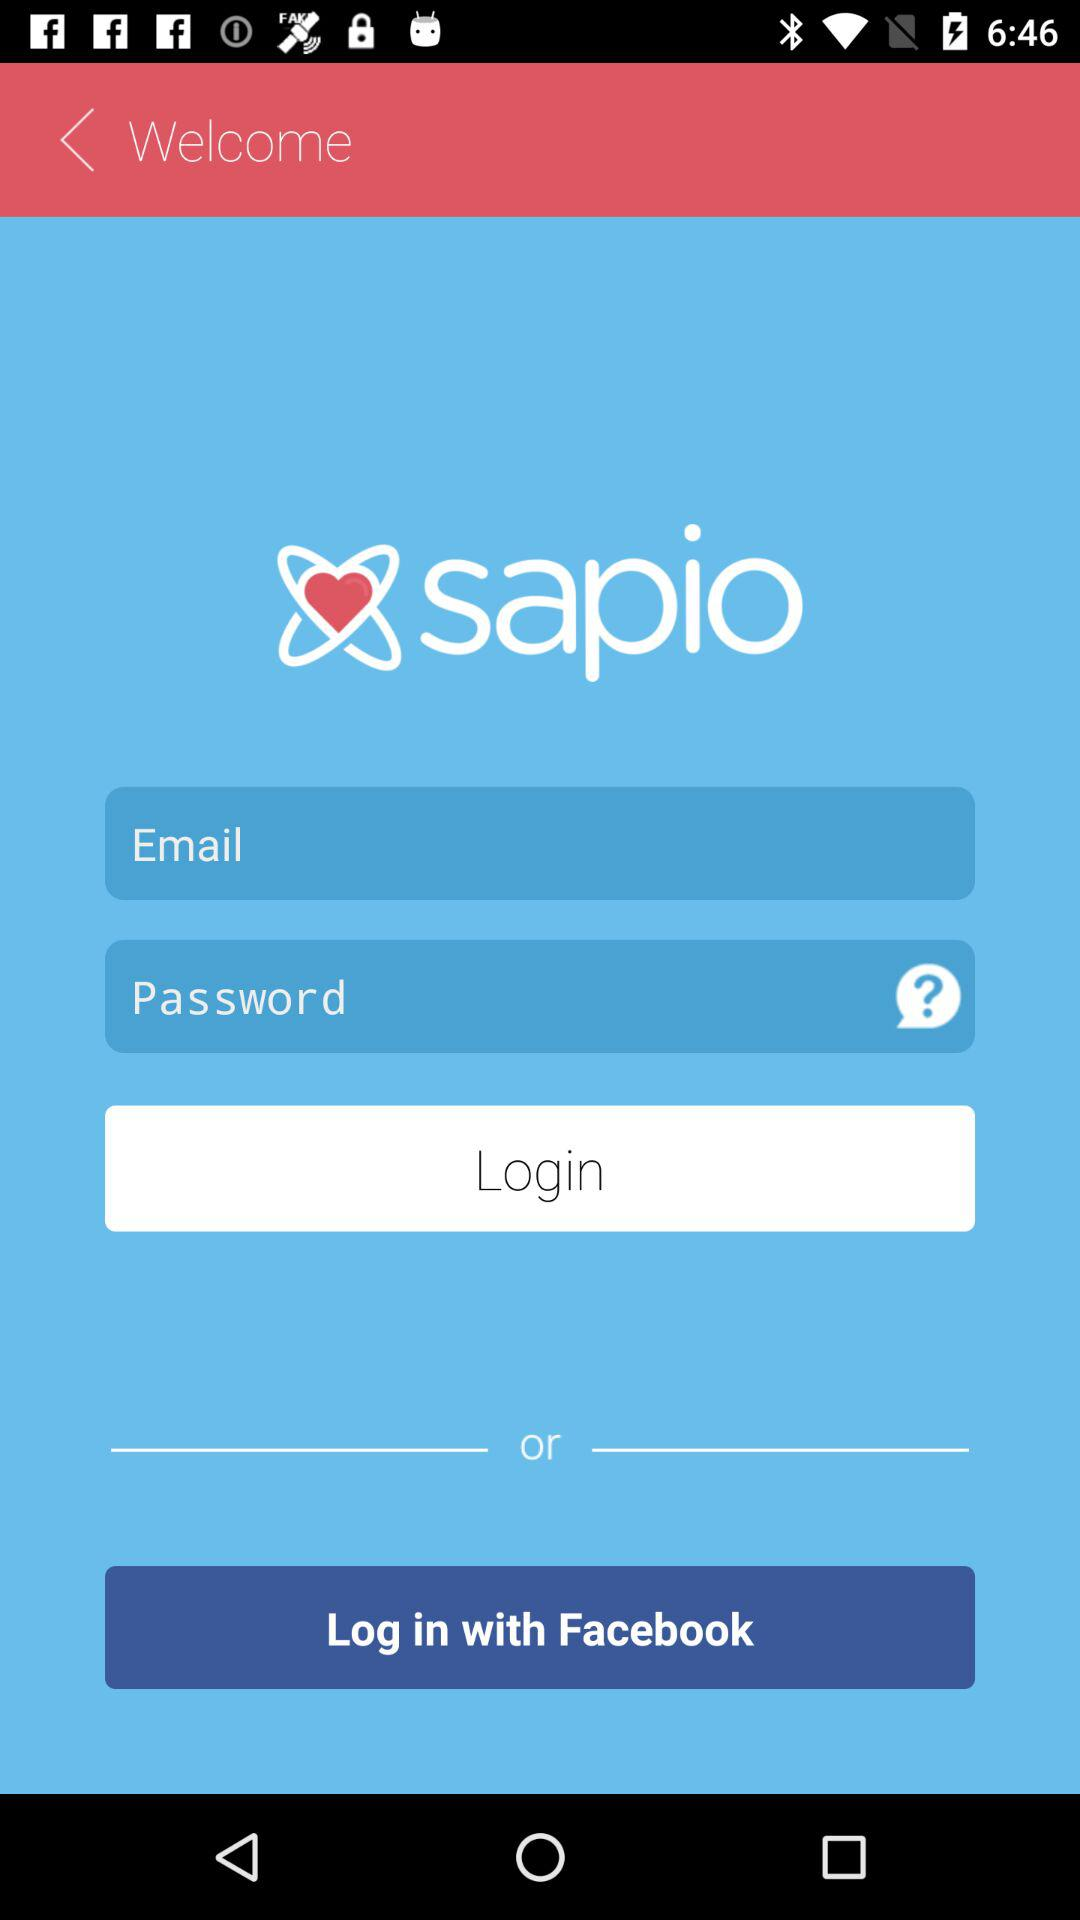What is the name of the application? The name of the application is "sapio". 